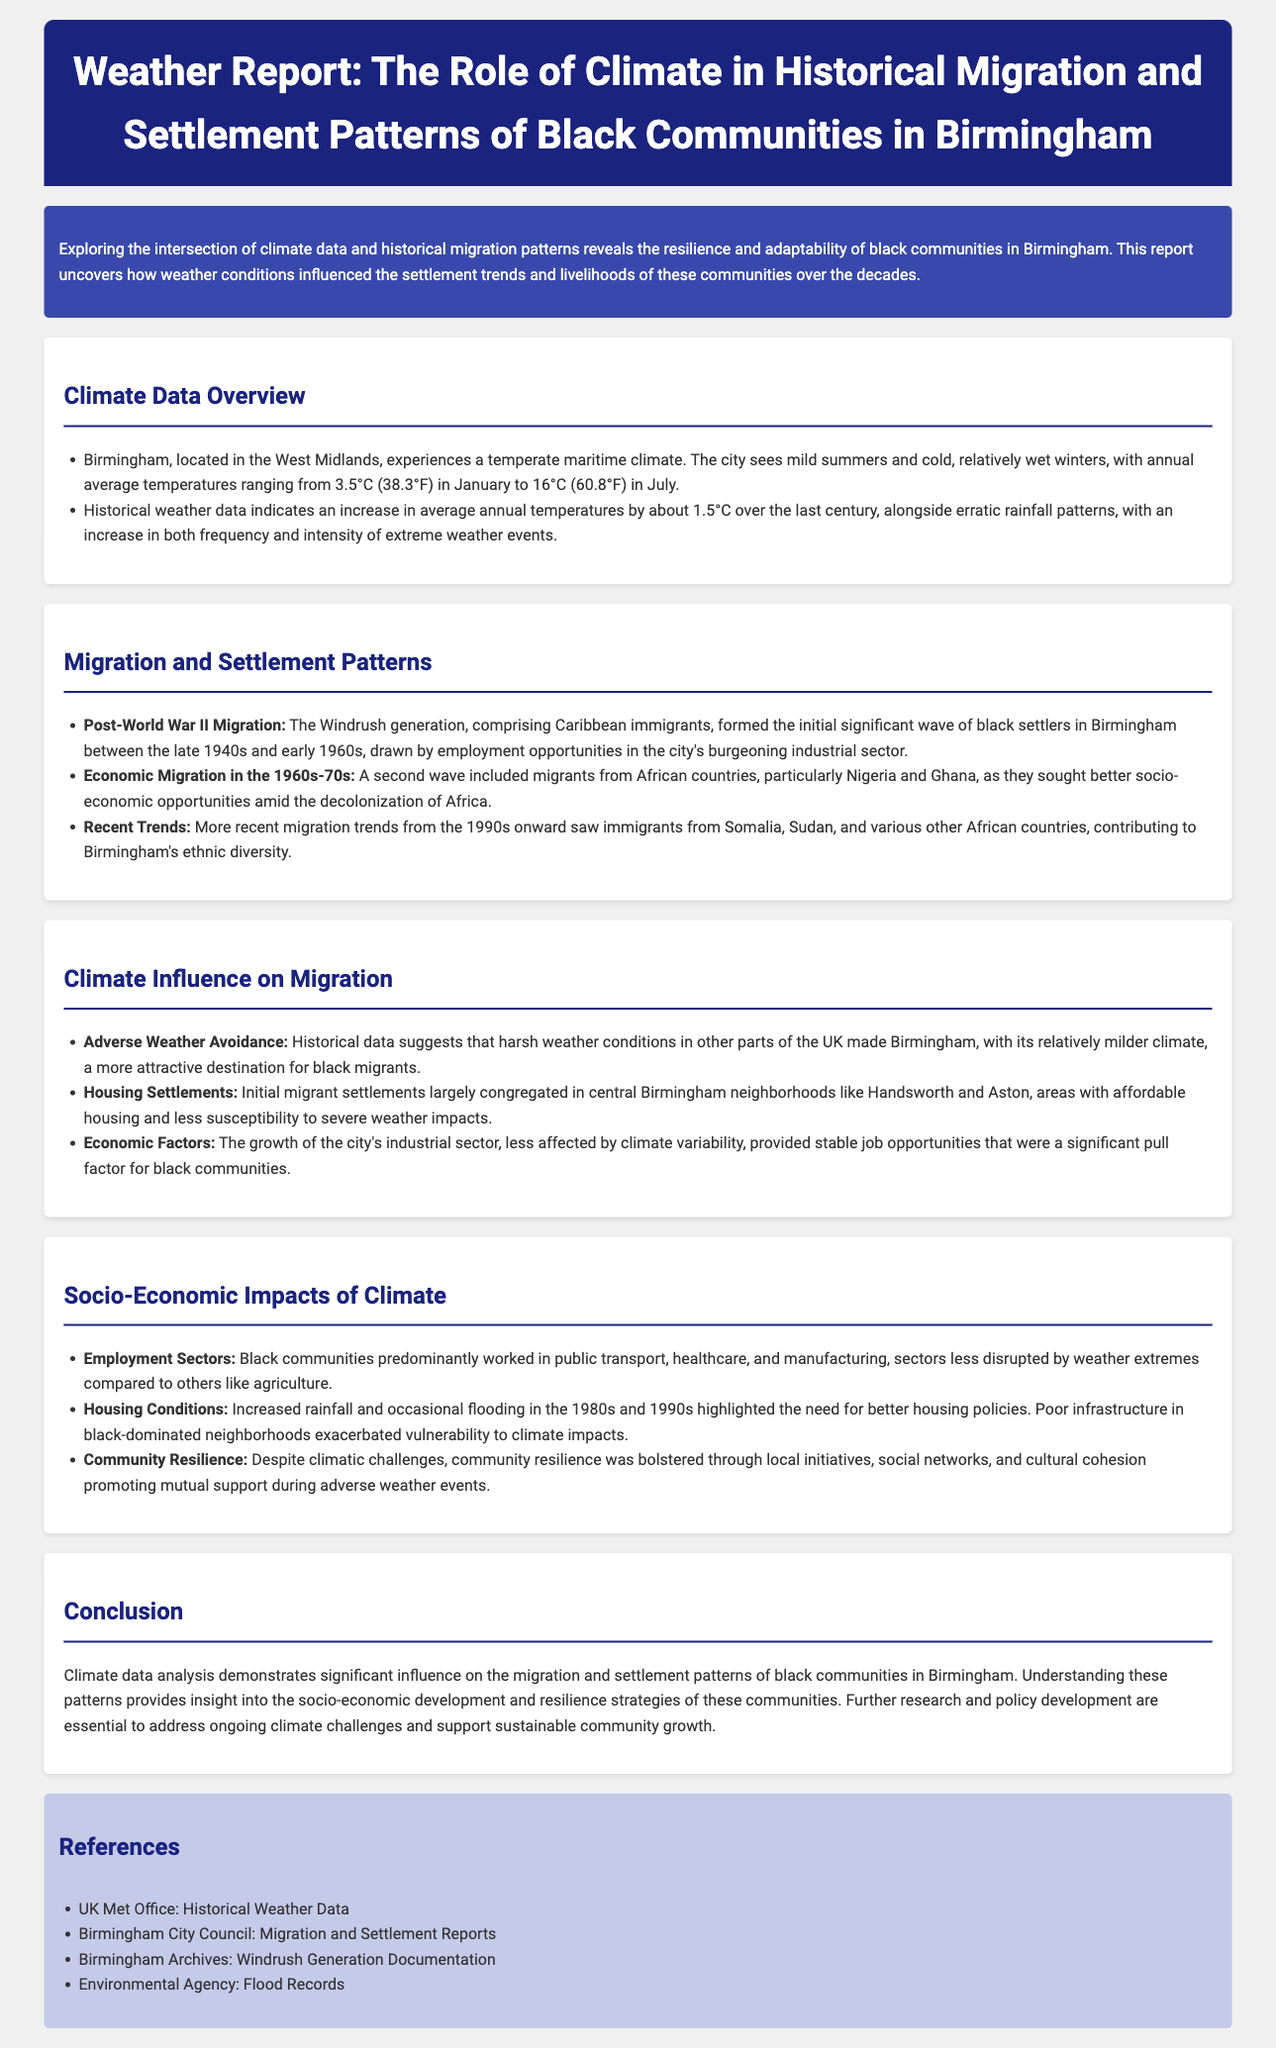What is the annual average temperature in July? The report states that the annual average temperature in July is 16°C (60.8°F).
Answer: 16°C (60.8°F) Who formed the initial significant wave of black settlers in Birmingham? The report identifies the Windrush generation as the initial significant wave of black settlers in Birmingham.
Answer: Windrush generation During which decades did economic migration from African countries occur? The document indicates that economic migration from African countries occurred in the 1960s-70s.
Answer: 1960s-70s What geographic area in Birmingham is noted for its affordable housing? Handsworth and Aston are mentioned as neighborhoods in Birmingham with affordable housing.
Answer: Handsworth and Aston What weather condition contributed to Birmingham being an attractive destination for black migrants? Historical data suggests that harsher weather conditions in other parts of the UK made Birmingham more attractive.
Answer: Harsh weather conditions What was the predominant sector of employment for black communities? The report indicates that black communities predominantly worked in public transport, healthcare, and manufacturing.
Answer: Public transport, healthcare, and manufacturing What climate-related issue was highlighted in black-dominated neighborhoods in the 1980s and 1990s? The increased rainfall and flooding in the 1980s and 1990s highlighted the need for better housing policies.
Answer: Better housing policies What do community initiatives promote during adverse weather events? The report mentions that local initiatives and social networks promote mutual support during adverse weather events.
Answer: Mutual support What is the purpose of analyzing climate data in relation to black communities? The report concludes that analyzing climate data helps understand the socio-economic development and resilience strategies of black communities.
Answer: Understand socio-economic development and resilience strategies 